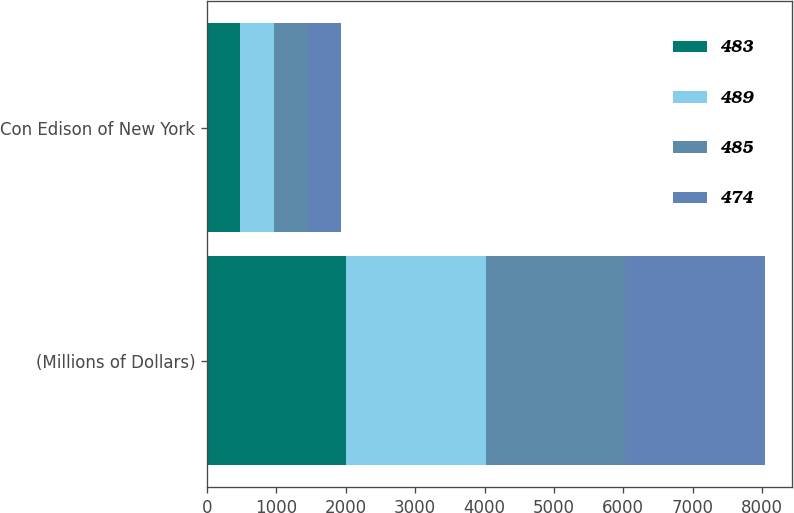<chart> <loc_0><loc_0><loc_500><loc_500><stacked_bar_chart><ecel><fcel>(Millions of Dollars)<fcel>Con Edison of New York<nl><fcel>483<fcel>2008<fcel>474<nl><fcel>489<fcel>2009<fcel>489<nl><fcel>485<fcel>2010<fcel>485<nl><fcel>474<fcel>2011<fcel>483<nl></chart> 